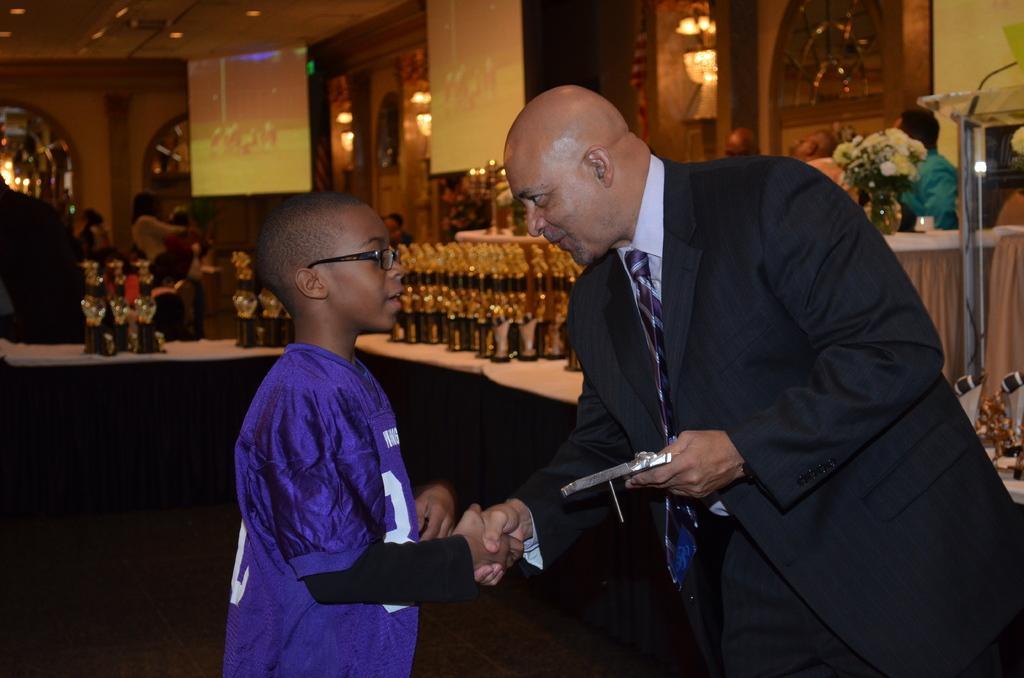Please provide a concise description of this image. In the picture I can see one person giving hand to one child. On the right of the picture I can see one flower bouquet. In the background, I can see the bottles. 